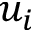Convert formula to latex. <formula><loc_0><loc_0><loc_500><loc_500>u _ { i }</formula> 